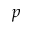Convert formula to latex. <formula><loc_0><loc_0><loc_500><loc_500>p</formula> 